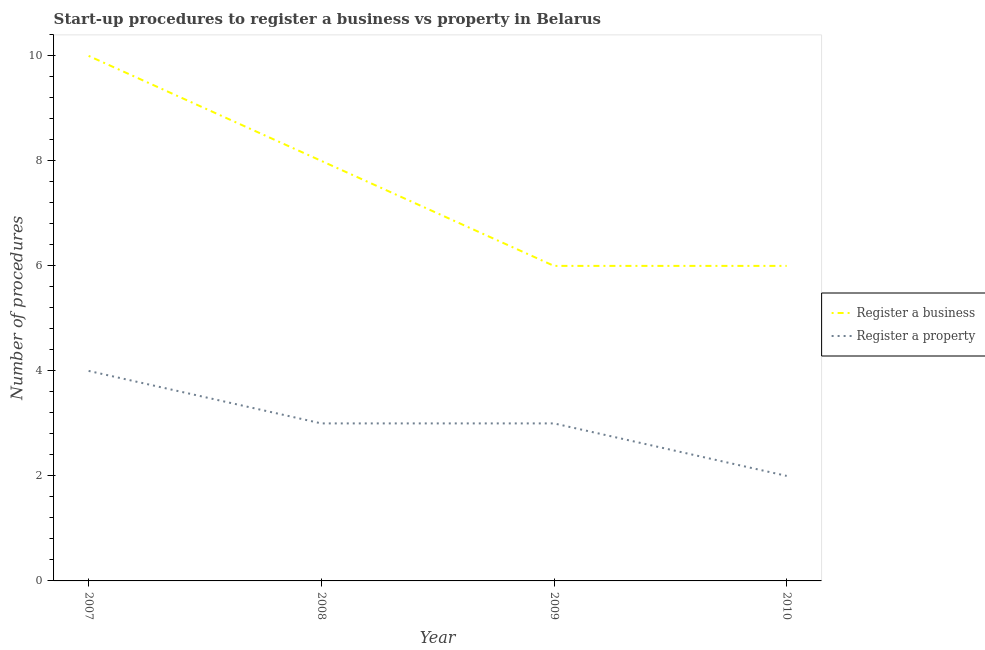Does the line corresponding to number of procedures to register a business intersect with the line corresponding to number of procedures to register a property?
Keep it short and to the point. No. Is the number of lines equal to the number of legend labels?
Ensure brevity in your answer.  Yes. What is the number of procedures to register a property in 2009?
Keep it short and to the point. 3. Across all years, what is the maximum number of procedures to register a property?
Your answer should be very brief. 4. Across all years, what is the minimum number of procedures to register a property?
Your answer should be compact. 2. In which year was the number of procedures to register a property maximum?
Your answer should be compact. 2007. What is the total number of procedures to register a business in the graph?
Offer a terse response. 30. What is the difference between the number of procedures to register a business in 2007 and that in 2008?
Offer a very short reply. 2. What is the difference between the number of procedures to register a property in 2007 and the number of procedures to register a business in 2010?
Provide a succinct answer. -2. In the year 2008, what is the difference between the number of procedures to register a property and number of procedures to register a business?
Offer a terse response. -5. In how many years, is the number of procedures to register a property greater than 4.8?
Give a very brief answer. 0. What is the ratio of the number of procedures to register a business in 2007 to that in 2008?
Provide a succinct answer. 1.25. What is the difference between the highest and the lowest number of procedures to register a property?
Your response must be concise. 2. Is the sum of the number of procedures to register a business in 2008 and 2010 greater than the maximum number of procedures to register a property across all years?
Provide a succinct answer. Yes. How many lines are there?
Your answer should be very brief. 2. How many years are there in the graph?
Offer a very short reply. 4. Are the values on the major ticks of Y-axis written in scientific E-notation?
Provide a succinct answer. No. Does the graph contain grids?
Offer a very short reply. No. What is the title of the graph?
Provide a short and direct response. Start-up procedures to register a business vs property in Belarus. Does "Current education expenditure" appear as one of the legend labels in the graph?
Offer a very short reply. No. What is the label or title of the X-axis?
Offer a very short reply. Year. What is the label or title of the Y-axis?
Provide a short and direct response. Number of procedures. What is the Number of procedures of Register a business in 2007?
Provide a succinct answer. 10. What is the Number of procedures of Register a property in 2007?
Offer a terse response. 4. What is the Number of procedures of Register a property in 2009?
Provide a succinct answer. 3. What is the Number of procedures of Register a property in 2010?
Make the answer very short. 2. Across all years, what is the maximum Number of procedures in Register a property?
Give a very brief answer. 4. What is the total Number of procedures in Register a business in the graph?
Give a very brief answer. 30. What is the difference between the Number of procedures in Register a property in 2007 and that in 2008?
Make the answer very short. 1. What is the difference between the Number of procedures of Register a property in 2007 and that in 2009?
Your answer should be very brief. 1. What is the difference between the Number of procedures of Register a business in 2007 and that in 2010?
Keep it short and to the point. 4. What is the difference between the Number of procedures of Register a property in 2007 and that in 2010?
Give a very brief answer. 2. What is the difference between the Number of procedures of Register a business in 2008 and that in 2010?
Offer a terse response. 2. What is the difference between the Number of procedures in Register a property in 2009 and that in 2010?
Offer a terse response. 1. What is the difference between the Number of procedures of Register a business in 2007 and the Number of procedures of Register a property in 2008?
Offer a terse response. 7. What is the difference between the Number of procedures in Register a business in 2008 and the Number of procedures in Register a property in 2009?
Make the answer very short. 5. What is the difference between the Number of procedures in Register a business in 2008 and the Number of procedures in Register a property in 2010?
Ensure brevity in your answer.  6. What is the difference between the Number of procedures of Register a business in 2009 and the Number of procedures of Register a property in 2010?
Your response must be concise. 4. What is the average Number of procedures in Register a property per year?
Make the answer very short. 3. In the year 2008, what is the difference between the Number of procedures in Register a business and Number of procedures in Register a property?
Offer a very short reply. 5. What is the ratio of the Number of procedures in Register a business in 2007 to that in 2008?
Your response must be concise. 1.25. What is the ratio of the Number of procedures of Register a property in 2007 to that in 2008?
Your response must be concise. 1.33. What is the ratio of the Number of procedures of Register a business in 2007 to that in 2009?
Make the answer very short. 1.67. What is the ratio of the Number of procedures in Register a property in 2007 to that in 2009?
Provide a short and direct response. 1.33. What is the ratio of the Number of procedures of Register a property in 2007 to that in 2010?
Your response must be concise. 2. What is the ratio of the Number of procedures of Register a property in 2009 to that in 2010?
Your answer should be compact. 1.5. What is the difference between the highest and the second highest Number of procedures in Register a business?
Ensure brevity in your answer.  2. What is the difference between the highest and the second highest Number of procedures of Register a property?
Your response must be concise. 1. What is the difference between the highest and the lowest Number of procedures of Register a property?
Make the answer very short. 2. 